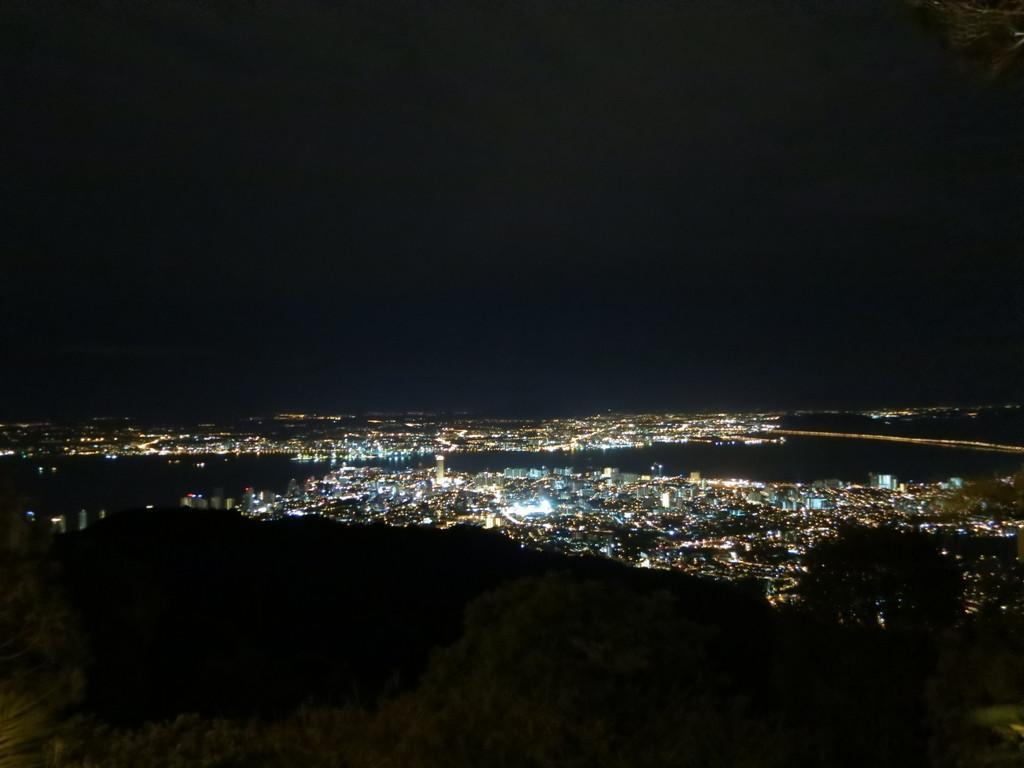In one or two sentences, can you explain what this image depicts? In this picture I can see a view of a place on which we can see some buildings, lights. 